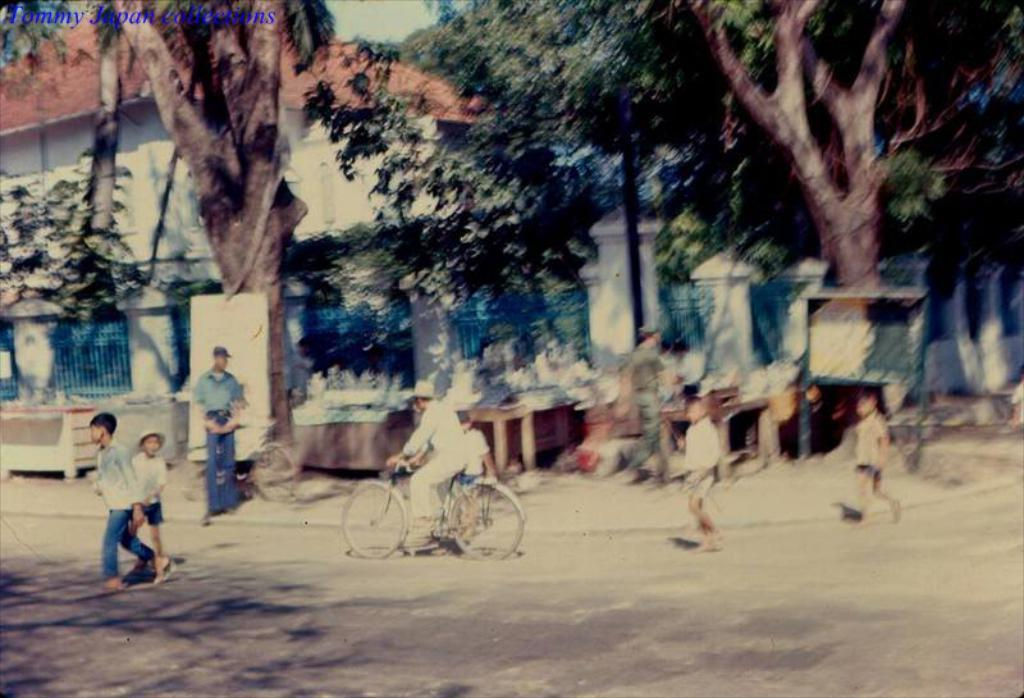What are the people in the image doing? There are persons standing on the road, and one person is sitting on a bicycle. What can be seen in the background of the image? There are buildings, trees, pillars, a grill, and the road visible in the background. What type of noise can be heard coming from the secretary's office in the image? There is no secretary's office present in the image, so it's not possible to determine what, if any, noise might be heard. 